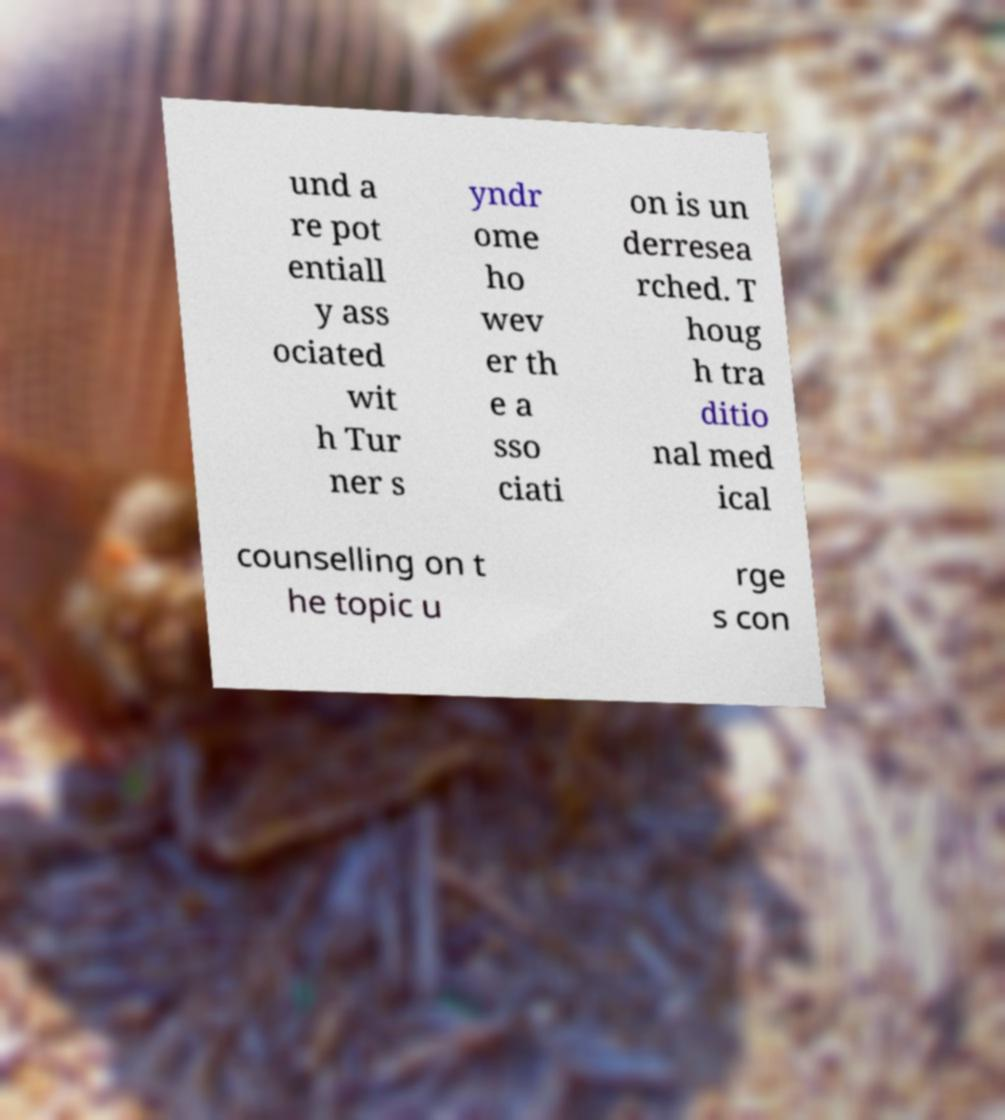What messages or text are displayed in this image? I need them in a readable, typed format. und a re pot entiall y ass ociated wit h Tur ner s yndr ome ho wev er th e a sso ciati on is un derresea rched. T houg h tra ditio nal med ical counselling on t he topic u rge s con 